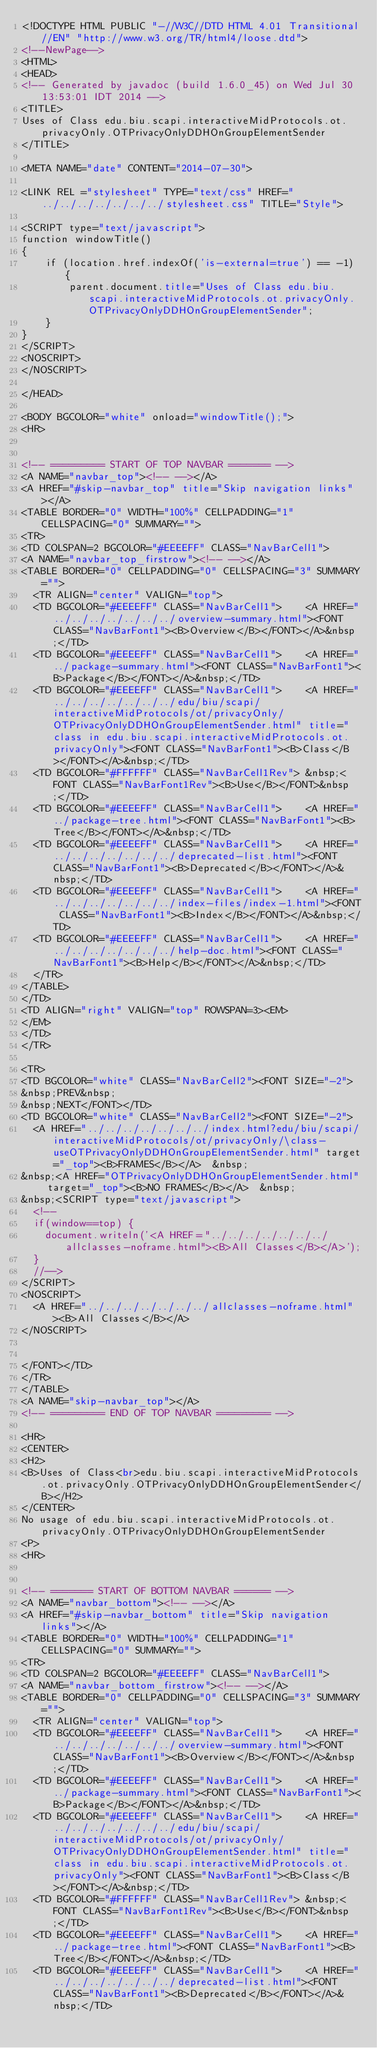Convert code to text. <code><loc_0><loc_0><loc_500><loc_500><_HTML_><!DOCTYPE HTML PUBLIC "-//W3C//DTD HTML 4.01 Transitional//EN" "http://www.w3.org/TR/html4/loose.dtd">
<!--NewPage-->
<HTML>
<HEAD>
<!-- Generated by javadoc (build 1.6.0_45) on Wed Jul 30 13:53:01 IDT 2014 -->
<TITLE>
Uses of Class edu.biu.scapi.interactiveMidProtocols.ot.privacyOnly.OTPrivacyOnlyDDHOnGroupElementSender
</TITLE>

<META NAME="date" CONTENT="2014-07-30">

<LINK REL ="stylesheet" TYPE="text/css" HREF="../../../../../../../stylesheet.css" TITLE="Style">

<SCRIPT type="text/javascript">
function windowTitle()
{
    if (location.href.indexOf('is-external=true') == -1) {
        parent.document.title="Uses of Class edu.biu.scapi.interactiveMidProtocols.ot.privacyOnly.OTPrivacyOnlyDDHOnGroupElementSender";
    }
}
</SCRIPT>
<NOSCRIPT>
</NOSCRIPT>

</HEAD>

<BODY BGCOLOR="white" onload="windowTitle();">
<HR>


<!-- ========= START OF TOP NAVBAR ======= -->
<A NAME="navbar_top"><!-- --></A>
<A HREF="#skip-navbar_top" title="Skip navigation links"></A>
<TABLE BORDER="0" WIDTH="100%" CELLPADDING="1" CELLSPACING="0" SUMMARY="">
<TR>
<TD COLSPAN=2 BGCOLOR="#EEEEFF" CLASS="NavBarCell1">
<A NAME="navbar_top_firstrow"><!-- --></A>
<TABLE BORDER="0" CELLPADDING="0" CELLSPACING="3" SUMMARY="">
  <TR ALIGN="center" VALIGN="top">
  <TD BGCOLOR="#EEEEFF" CLASS="NavBarCell1">    <A HREF="../../../../../../../overview-summary.html"><FONT CLASS="NavBarFont1"><B>Overview</B></FONT></A>&nbsp;</TD>
  <TD BGCOLOR="#EEEEFF" CLASS="NavBarCell1">    <A HREF="../package-summary.html"><FONT CLASS="NavBarFont1"><B>Package</B></FONT></A>&nbsp;</TD>
  <TD BGCOLOR="#EEEEFF" CLASS="NavBarCell1">    <A HREF="../../../../../../../edu/biu/scapi/interactiveMidProtocols/ot/privacyOnly/OTPrivacyOnlyDDHOnGroupElementSender.html" title="class in edu.biu.scapi.interactiveMidProtocols.ot.privacyOnly"><FONT CLASS="NavBarFont1"><B>Class</B></FONT></A>&nbsp;</TD>
  <TD BGCOLOR="#FFFFFF" CLASS="NavBarCell1Rev"> &nbsp;<FONT CLASS="NavBarFont1Rev"><B>Use</B></FONT>&nbsp;</TD>
  <TD BGCOLOR="#EEEEFF" CLASS="NavBarCell1">    <A HREF="../package-tree.html"><FONT CLASS="NavBarFont1"><B>Tree</B></FONT></A>&nbsp;</TD>
  <TD BGCOLOR="#EEEEFF" CLASS="NavBarCell1">    <A HREF="../../../../../../../deprecated-list.html"><FONT CLASS="NavBarFont1"><B>Deprecated</B></FONT></A>&nbsp;</TD>
  <TD BGCOLOR="#EEEEFF" CLASS="NavBarCell1">    <A HREF="../../../../../../../index-files/index-1.html"><FONT CLASS="NavBarFont1"><B>Index</B></FONT></A>&nbsp;</TD>
  <TD BGCOLOR="#EEEEFF" CLASS="NavBarCell1">    <A HREF="../../../../../../../help-doc.html"><FONT CLASS="NavBarFont1"><B>Help</B></FONT></A>&nbsp;</TD>
  </TR>
</TABLE>
</TD>
<TD ALIGN="right" VALIGN="top" ROWSPAN=3><EM>
</EM>
</TD>
</TR>

<TR>
<TD BGCOLOR="white" CLASS="NavBarCell2"><FONT SIZE="-2">
&nbsp;PREV&nbsp;
&nbsp;NEXT</FONT></TD>
<TD BGCOLOR="white" CLASS="NavBarCell2"><FONT SIZE="-2">
  <A HREF="../../../../../../../index.html?edu/biu/scapi/interactiveMidProtocols/ot/privacyOnly/\class-useOTPrivacyOnlyDDHOnGroupElementSender.html" target="_top"><B>FRAMES</B></A>  &nbsp;
&nbsp;<A HREF="OTPrivacyOnlyDDHOnGroupElementSender.html" target="_top"><B>NO FRAMES</B></A>  &nbsp;
&nbsp;<SCRIPT type="text/javascript">
  <!--
  if(window==top) {
    document.writeln('<A HREF="../../../../../../../allclasses-noframe.html"><B>All Classes</B></A>');
  }
  //-->
</SCRIPT>
<NOSCRIPT>
  <A HREF="../../../../../../../allclasses-noframe.html"><B>All Classes</B></A>
</NOSCRIPT>


</FONT></TD>
</TR>
</TABLE>
<A NAME="skip-navbar_top"></A>
<!-- ========= END OF TOP NAVBAR ========= -->

<HR>
<CENTER>
<H2>
<B>Uses of Class<br>edu.biu.scapi.interactiveMidProtocols.ot.privacyOnly.OTPrivacyOnlyDDHOnGroupElementSender</B></H2>
</CENTER>
No usage of edu.biu.scapi.interactiveMidProtocols.ot.privacyOnly.OTPrivacyOnlyDDHOnGroupElementSender
<P>
<HR>


<!-- ======= START OF BOTTOM NAVBAR ====== -->
<A NAME="navbar_bottom"><!-- --></A>
<A HREF="#skip-navbar_bottom" title="Skip navigation links"></A>
<TABLE BORDER="0" WIDTH="100%" CELLPADDING="1" CELLSPACING="0" SUMMARY="">
<TR>
<TD COLSPAN=2 BGCOLOR="#EEEEFF" CLASS="NavBarCell1">
<A NAME="navbar_bottom_firstrow"><!-- --></A>
<TABLE BORDER="0" CELLPADDING="0" CELLSPACING="3" SUMMARY="">
  <TR ALIGN="center" VALIGN="top">
  <TD BGCOLOR="#EEEEFF" CLASS="NavBarCell1">    <A HREF="../../../../../../../overview-summary.html"><FONT CLASS="NavBarFont1"><B>Overview</B></FONT></A>&nbsp;</TD>
  <TD BGCOLOR="#EEEEFF" CLASS="NavBarCell1">    <A HREF="../package-summary.html"><FONT CLASS="NavBarFont1"><B>Package</B></FONT></A>&nbsp;</TD>
  <TD BGCOLOR="#EEEEFF" CLASS="NavBarCell1">    <A HREF="../../../../../../../edu/biu/scapi/interactiveMidProtocols/ot/privacyOnly/OTPrivacyOnlyDDHOnGroupElementSender.html" title="class in edu.biu.scapi.interactiveMidProtocols.ot.privacyOnly"><FONT CLASS="NavBarFont1"><B>Class</B></FONT></A>&nbsp;</TD>
  <TD BGCOLOR="#FFFFFF" CLASS="NavBarCell1Rev"> &nbsp;<FONT CLASS="NavBarFont1Rev"><B>Use</B></FONT>&nbsp;</TD>
  <TD BGCOLOR="#EEEEFF" CLASS="NavBarCell1">    <A HREF="../package-tree.html"><FONT CLASS="NavBarFont1"><B>Tree</B></FONT></A>&nbsp;</TD>
  <TD BGCOLOR="#EEEEFF" CLASS="NavBarCell1">    <A HREF="../../../../../../../deprecated-list.html"><FONT CLASS="NavBarFont1"><B>Deprecated</B></FONT></A>&nbsp;</TD></code> 